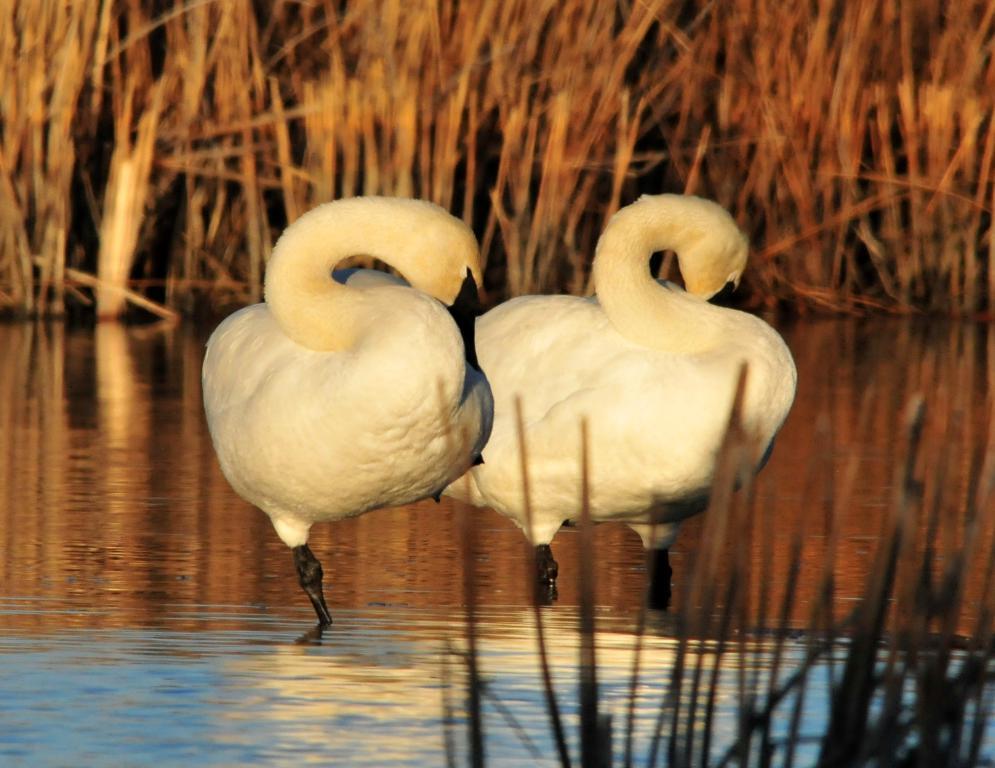Could you give a brief overview of what you see in this image? In this image we can see two birds standing in the water. Also there is grass. 